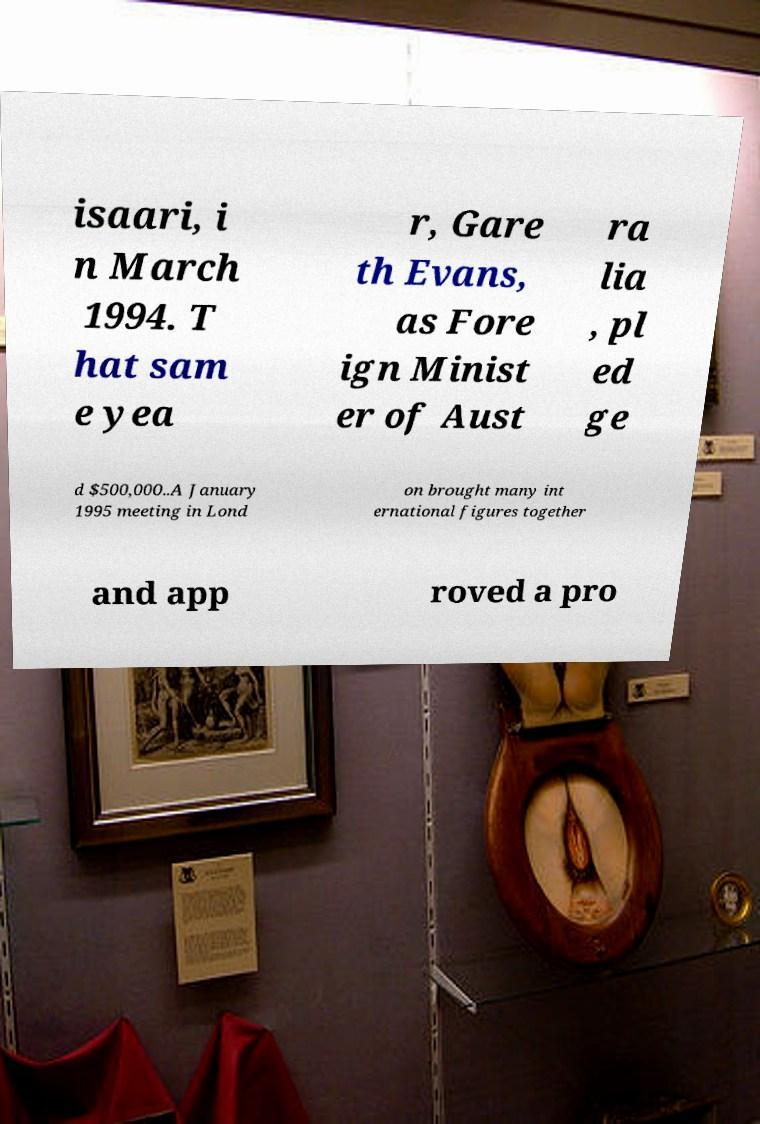I need the written content from this picture converted into text. Can you do that? isaari, i n March 1994. T hat sam e yea r, Gare th Evans, as Fore ign Minist er of Aust ra lia , pl ed ge d $500,000..A January 1995 meeting in Lond on brought many int ernational figures together and app roved a pro 